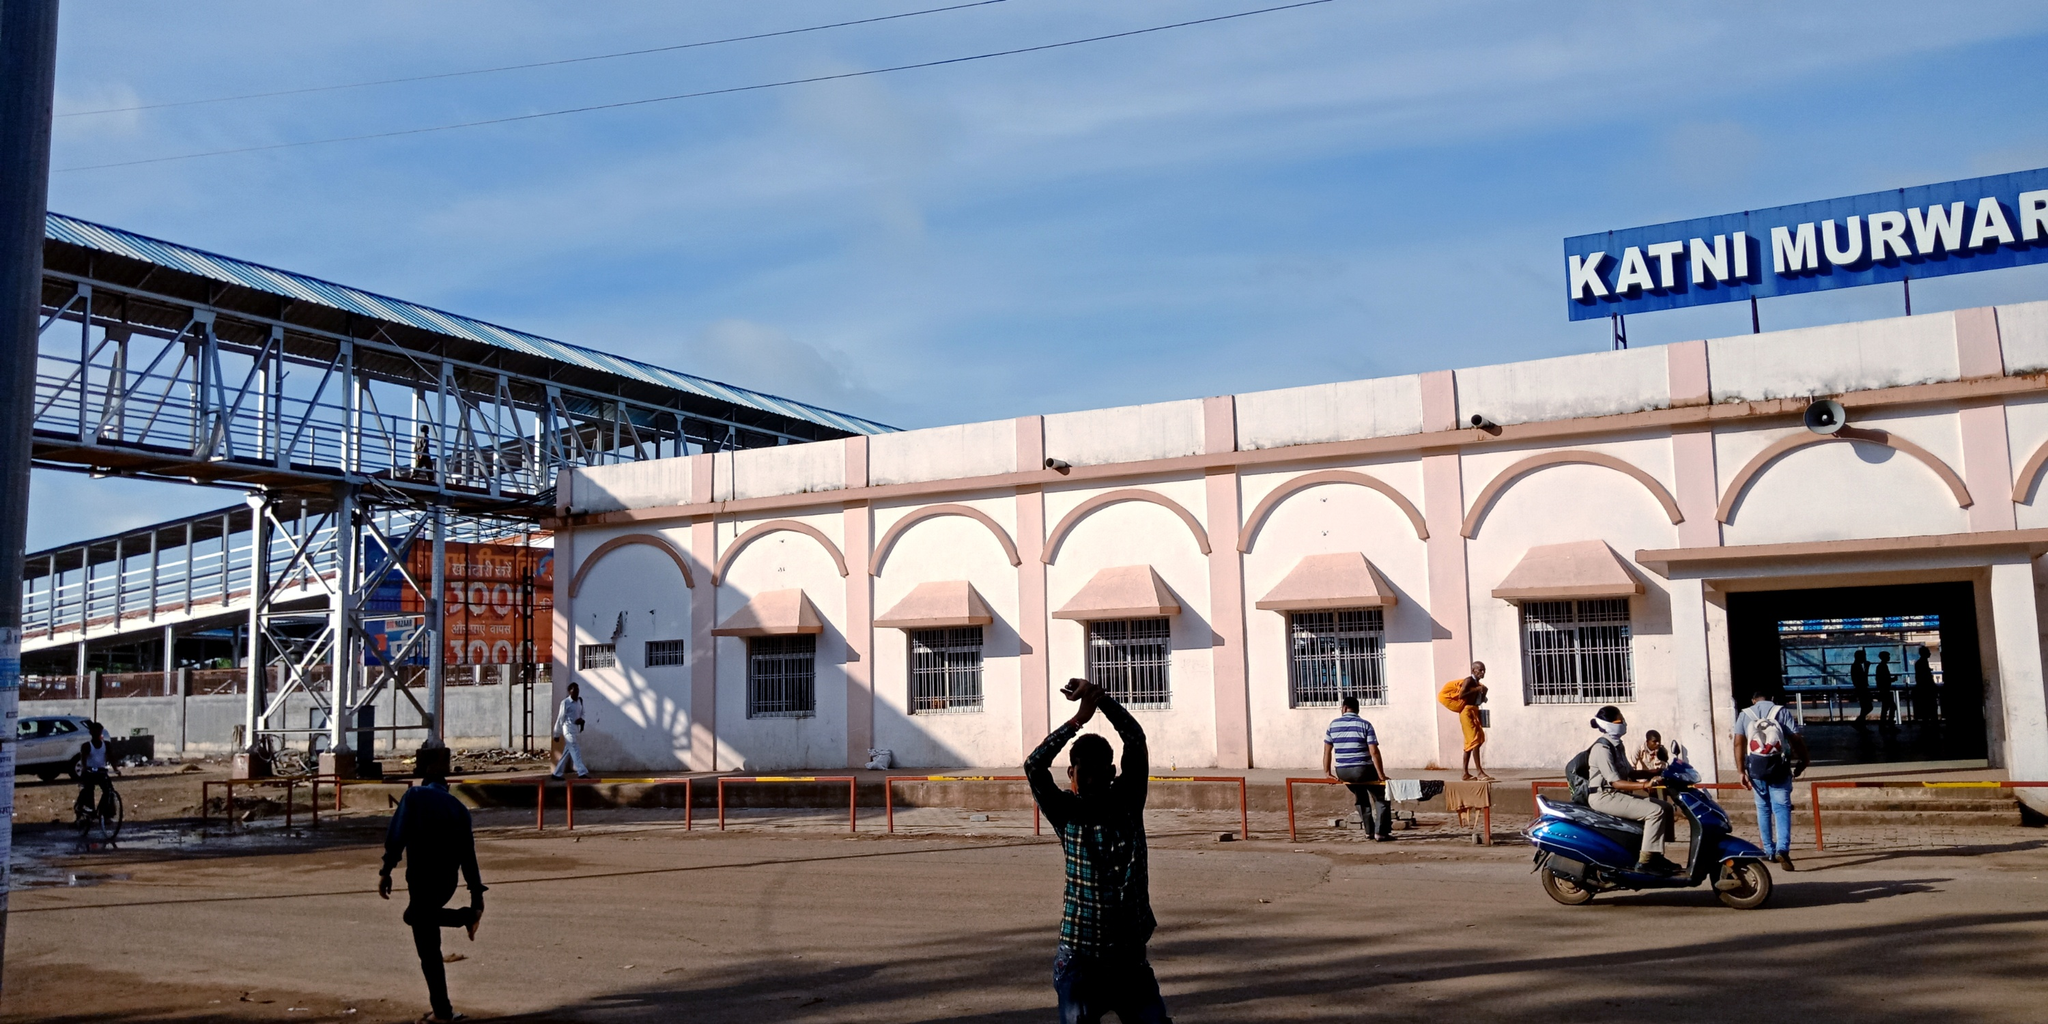Can you tell more about the activities of the people near the station? The image shows a variety of activities near the station. A man in a green shirt is engaged in taking a photo, capturing a moment or a particular aspect of the station. Another individual, wearing a white cap, is walking by, possibly a traveler or a local commuter. Near the main entrance, a few more people can be seen possibly waiting or just arrived, reflecting the everyday hustle of a railway station. These activities suggest a lively yet routine atmosphere typical of a busy railway hub. 